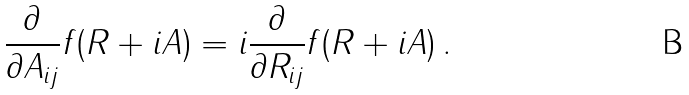<formula> <loc_0><loc_0><loc_500><loc_500>\frac { \partial } { \partial A _ { i j } } f ( R + i A ) = i \frac { \partial } { \partial R _ { i j } } f ( R + i A ) \, .</formula> 